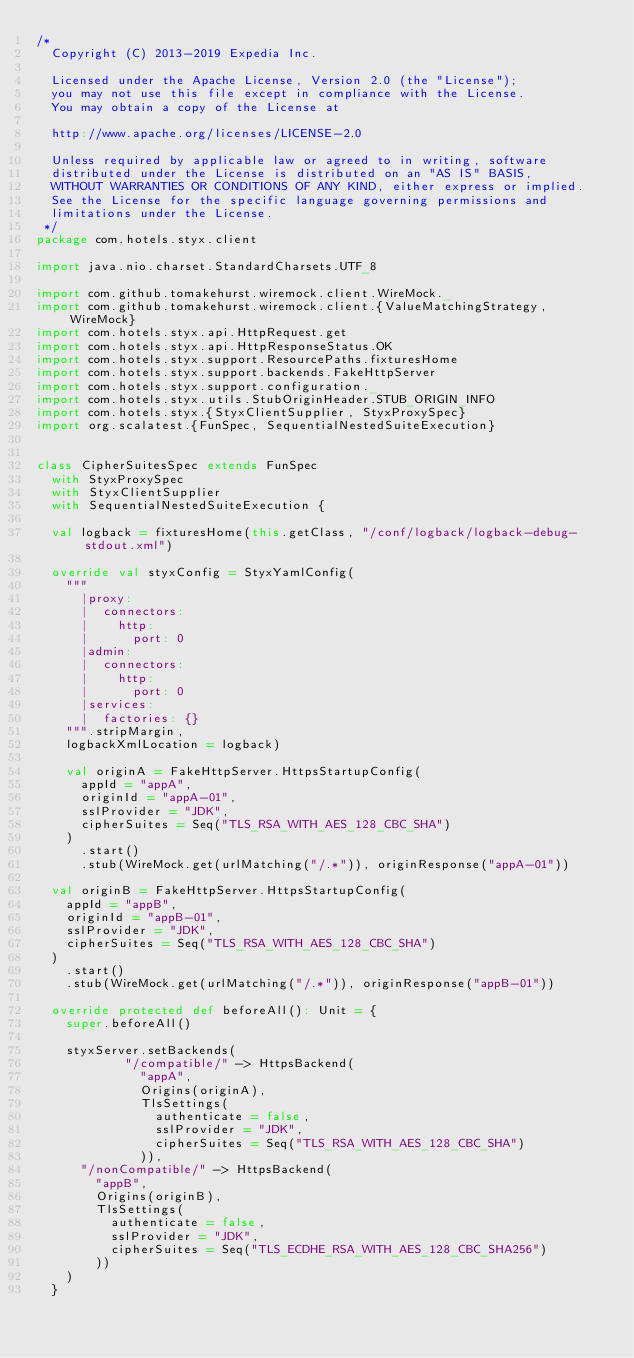Convert code to text. <code><loc_0><loc_0><loc_500><loc_500><_Scala_>/*
  Copyright (C) 2013-2019 Expedia Inc.

  Licensed under the Apache License, Version 2.0 (the "License");
  you may not use this file except in compliance with the License.
  You may obtain a copy of the License at

  http://www.apache.org/licenses/LICENSE-2.0

  Unless required by applicable law or agreed to in writing, software
  distributed under the License is distributed on an "AS IS" BASIS,
  WITHOUT WARRANTIES OR CONDITIONS OF ANY KIND, either express or implied.
  See the License for the specific language governing permissions and
  limitations under the License.
 */
package com.hotels.styx.client

import java.nio.charset.StandardCharsets.UTF_8

import com.github.tomakehurst.wiremock.client.WireMock._
import com.github.tomakehurst.wiremock.client.{ValueMatchingStrategy, WireMock}
import com.hotels.styx.api.HttpRequest.get
import com.hotels.styx.api.HttpResponseStatus.OK
import com.hotels.styx.support.ResourcePaths.fixturesHome
import com.hotels.styx.support.backends.FakeHttpServer
import com.hotels.styx.support.configuration._
import com.hotels.styx.utils.StubOriginHeader.STUB_ORIGIN_INFO
import com.hotels.styx.{StyxClientSupplier, StyxProxySpec}
import org.scalatest.{FunSpec, SequentialNestedSuiteExecution}


class CipherSuitesSpec extends FunSpec
  with StyxProxySpec
  with StyxClientSupplier
  with SequentialNestedSuiteExecution {

  val logback = fixturesHome(this.getClass, "/conf/logback/logback-debug-stdout.xml")

  override val styxConfig = StyxYamlConfig(
    """
      |proxy:
      |  connectors:
      |    http:
      |      port: 0
      |admin:
      |  connectors:
      |    http:
      |      port: 0
      |services:
      |  factories: {}
    """.stripMargin,
    logbackXmlLocation = logback)

    val originA = FakeHttpServer.HttpsStartupConfig(
      appId = "appA",
      originId = "appA-01",
      sslProvider = "JDK",
      cipherSuites = Seq("TLS_RSA_WITH_AES_128_CBC_SHA")
    )
      .start()
      .stub(WireMock.get(urlMatching("/.*")), originResponse("appA-01"))

  val originB = FakeHttpServer.HttpsStartupConfig(
    appId = "appB",
    originId = "appB-01",
    sslProvider = "JDK",
    cipherSuites = Seq("TLS_RSA_WITH_AES_128_CBC_SHA")
  )
    .start()
    .stub(WireMock.get(urlMatching("/.*")), originResponse("appB-01"))

  override protected def beforeAll(): Unit = {
    super.beforeAll()

    styxServer.setBackends(
            "/compatible/" -> HttpsBackend(
              "appA",
              Origins(originA),
              TlsSettings(
                authenticate = false,
                sslProvider = "JDK",
                cipherSuites = Seq("TLS_RSA_WITH_AES_128_CBC_SHA")
              )),
      "/nonCompatible/" -> HttpsBackend(
        "appB",
        Origins(originB),
        TlsSettings(
          authenticate = false,
          sslProvider = "JDK",
          cipherSuites = Seq("TLS_ECDHE_RSA_WITH_AES_128_CBC_SHA256")
        ))
    )
  }
</code> 